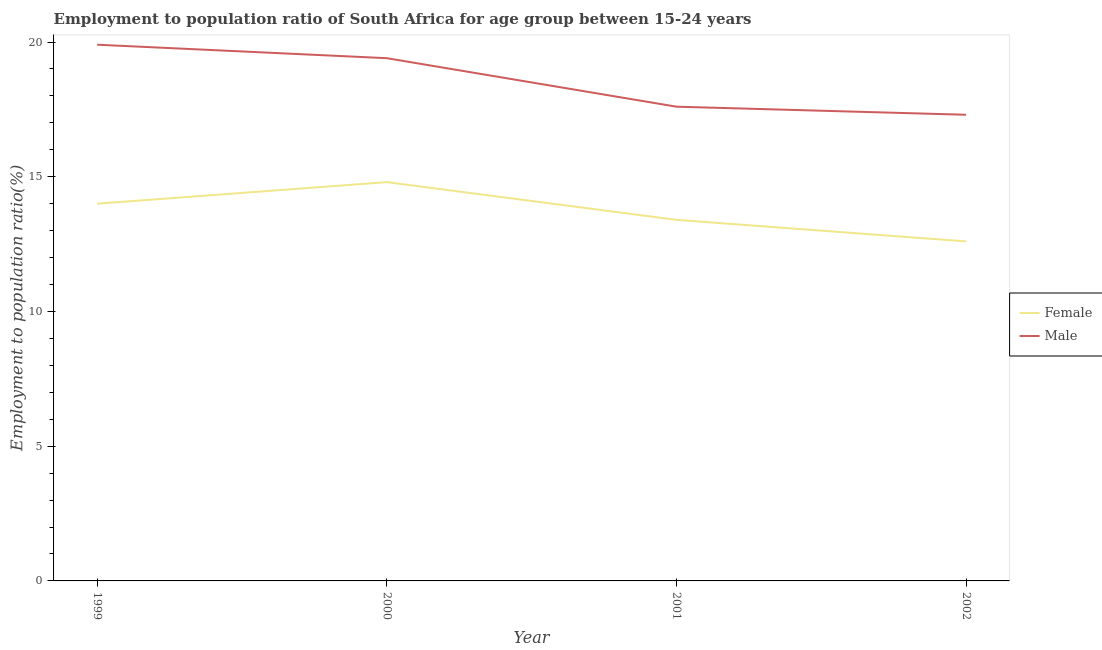How many different coloured lines are there?
Offer a very short reply. 2. Does the line corresponding to employment to population ratio(female) intersect with the line corresponding to employment to population ratio(male)?
Your answer should be compact. No. What is the employment to population ratio(female) in 2002?
Provide a short and direct response. 12.6. Across all years, what is the maximum employment to population ratio(female)?
Provide a short and direct response. 14.8. Across all years, what is the minimum employment to population ratio(male)?
Keep it short and to the point. 17.3. In which year was the employment to population ratio(male) maximum?
Your response must be concise. 1999. What is the total employment to population ratio(male) in the graph?
Your answer should be very brief. 74.2. What is the difference between the employment to population ratio(male) in 1999 and that in 2001?
Ensure brevity in your answer.  2.3. What is the difference between the employment to population ratio(male) in 2001 and the employment to population ratio(female) in 1999?
Your answer should be very brief. 3.6. What is the average employment to population ratio(male) per year?
Your answer should be compact. 18.55. In the year 1999, what is the difference between the employment to population ratio(male) and employment to population ratio(female)?
Provide a short and direct response. 5.9. In how many years, is the employment to population ratio(male) greater than 5 %?
Your answer should be compact. 4. What is the ratio of the employment to population ratio(male) in 2001 to that in 2002?
Offer a terse response. 1.02. What is the difference between the highest and the second highest employment to population ratio(male)?
Provide a succinct answer. 0.5. What is the difference between the highest and the lowest employment to population ratio(male)?
Make the answer very short. 2.6. In how many years, is the employment to population ratio(male) greater than the average employment to population ratio(male) taken over all years?
Your answer should be compact. 2. What is the difference between two consecutive major ticks on the Y-axis?
Ensure brevity in your answer.  5. Does the graph contain any zero values?
Offer a terse response. No. How are the legend labels stacked?
Ensure brevity in your answer.  Vertical. What is the title of the graph?
Your answer should be very brief. Employment to population ratio of South Africa for age group between 15-24 years. Does "From production" appear as one of the legend labels in the graph?
Your response must be concise. No. What is the label or title of the X-axis?
Offer a very short reply. Year. What is the label or title of the Y-axis?
Ensure brevity in your answer.  Employment to population ratio(%). What is the Employment to population ratio(%) of Female in 1999?
Your answer should be very brief. 14. What is the Employment to population ratio(%) of Male in 1999?
Offer a terse response. 19.9. What is the Employment to population ratio(%) in Female in 2000?
Offer a terse response. 14.8. What is the Employment to population ratio(%) of Male in 2000?
Make the answer very short. 19.4. What is the Employment to population ratio(%) in Female in 2001?
Keep it short and to the point. 13.4. What is the Employment to population ratio(%) in Male in 2001?
Offer a very short reply. 17.6. What is the Employment to population ratio(%) in Female in 2002?
Provide a short and direct response. 12.6. What is the Employment to population ratio(%) of Male in 2002?
Give a very brief answer. 17.3. Across all years, what is the maximum Employment to population ratio(%) of Female?
Make the answer very short. 14.8. Across all years, what is the maximum Employment to population ratio(%) in Male?
Ensure brevity in your answer.  19.9. Across all years, what is the minimum Employment to population ratio(%) in Female?
Your answer should be very brief. 12.6. Across all years, what is the minimum Employment to population ratio(%) of Male?
Provide a succinct answer. 17.3. What is the total Employment to population ratio(%) of Female in the graph?
Your response must be concise. 54.8. What is the total Employment to population ratio(%) of Male in the graph?
Provide a succinct answer. 74.2. What is the difference between the Employment to population ratio(%) in Female in 1999 and that in 2000?
Ensure brevity in your answer.  -0.8. What is the difference between the Employment to population ratio(%) of Male in 1999 and that in 2000?
Make the answer very short. 0.5. What is the difference between the Employment to population ratio(%) of Female in 1999 and that in 2001?
Your answer should be compact. 0.6. What is the difference between the Employment to population ratio(%) of Male in 1999 and that in 2001?
Your response must be concise. 2.3. What is the difference between the Employment to population ratio(%) of Male in 1999 and that in 2002?
Give a very brief answer. 2.6. What is the difference between the Employment to population ratio(%) in Female in 2000 and that in 2001?
Keep it short and to the point. 1.4. What is the difference between the Employment to population ratio(%) in Female in 2000 and that in 2002?
Your response must be concise. 2.2. What is the difference between the Employment to population ratio(%) in Male in 2000 and that in 2002?
Provide a succinct answer. 2.1. What is the difference between the Employment to population ratio(%) in Female in 2001 and that in 2002?
Offer a very short reply. 0.8. What is the difference between the Employment to population ratio(%) of Male in 2001 and that in 2002?
Make the answer very short. 0.3. What is the difference between the Employment to population ratio(%) in Female in 1999 and the Employment to population ratio(%) in Male in 2000?
Offer a terse response. -5.4. What is the difference between the Employment to population ratio(%) of Female in 2000 and the Employment to population ratio(%) of Male in 2002?
Make the answer very short. -2.5. What is the difference between the Employment to population ratio(%) in Female in 2001 and the Employment to population ratio(%) in Male in 2002?
Your answer should be compact. -3.9. What is the average Employment to population ratio(%) in Male per year?
Offer a very short reply. 18.55. In the year 1999, what is the difference between the Employment to population ratio(%) of Female and Employment to population ratio(%) of Male?
Make the answer very short. -5.9. In the year 2000, what is the difference between the Employment to population ratio(%) of Female and Employment to population ratio(%) of Male?
Provide a short and direct response. -4.6. In the year 2002, what is the difference between the Employment to population ratio(%) of Female and Employment to population ratio(%) of Male?
Your response must be concise. -4.7. What is the ratio of the Employment to population ratio(%) of Female in 1999 to that in 2000?
Make the answer very short. 0.95. What is the ratio of the Employment to population ratio(%) in Male in 1999 to that in 2000?
Provide a succinct answer. 1.03. What is the ratio of the Employment to population ratio(%) of Female in 1999 to that in 2001?
Give a very brief answer. 1.04. What is the ratio of the Employment to population ratio(%) in Male in 1999 to that in 2001?
Your answer should be very brief. 1.13. What is the ratio of the Employment to population ratio(%) in Female in 1999 to that in 2002?
Your response must be concise. 1.11. What is the ratio of the Employment to population ratio(%) in Male in 1999 to that in 2002?
Offer a very short reply. 1.15. What is the ratio of the Employment to population ratio(%) of Female in 2000 to that in 2001?
Give a very brief answer. 1.1. What is the ratio of the Employment to population ratio(%) in Male in 2000 to that in 2001?
Your answer should be very brief. 1.1. What is the ratio of the Employment to population ratio(%) in Female in 2000 to that in 2002?
Your answer should be compact. 1.17. What is the ratio of the Employment to population ratio(%) of Male in 2000 to that in 2002?
Offer a very short reply. 1.12. What is the ratio of the Employment to population ratio(%) of Female in 2001 to that in 2002?
Make the answer very short. 1.06. What is the ratio of the Employment to population ratio(%) of Male in 2001 to that in 2002?
Keep it short and to the point. 1.02. What is the difference between the highest and the lowest Employment to population ratio(%) of Female?
Your response must be concise. 2.2. What is the difference between the highest and the lowest Employment to population ratio(%) in Male?
Your answer should be compact. 2.6. 